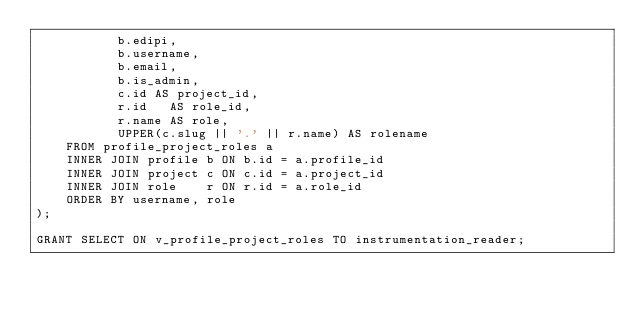<code> <loc_0><loc_0><loc_500><loc_500><_SQL_>           b.edipi,
           b.username,
           b.email,
           b.is_admin,
           c.id AS project_id,
           r.id   AS role_id,
           r.name AS role,
           UPPER(c.slug || '.' || r.name) AS rolename
    FROM profile_project_roles a
    INNER JOIN profile b ON b.id = a.profile_id
    INNER JOIN project c ON c.id = a.project_id
    INNER JOIN role    r ON r.id = a.role_id
    ORDER BY username, role
);

GRANT SELECT ON v_profile_project_roles TO instrumentation_reader;</code> 